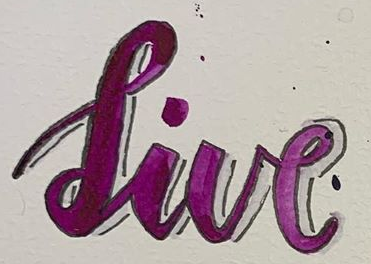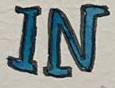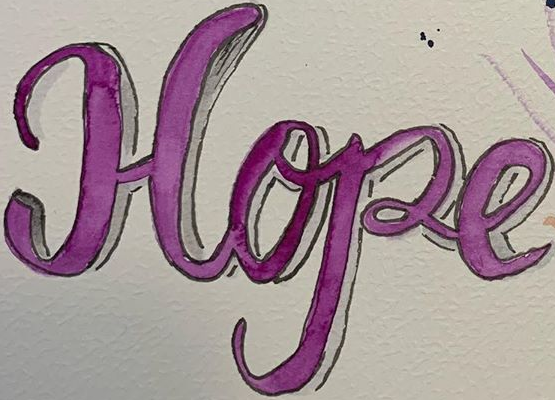Transcribe the words shown in these images in order, separated by a semicolon. live; IN; Hope 